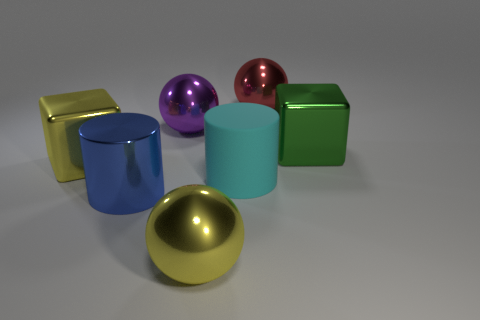Are there any other things that are the same material as the cyan object?
Your response must be concise. No. What material is the cyan object that is the same size as the purple object?
Offer a terse response. Rubber. How many cyan objects are large rubber spheres or rubber cylinders?
Offer a terse response. 1. There is a big object that is to the right of the large rubber cylinder and in front of the big purple metallic object; what color is it?
Provide a short and direct response. Green. Is the material of the red ball that is on the right side of the big purple object the same as the large cube left of the large blue cylinder?
Ensure brevity in your answer.  Yes. Are there more big yellow balls on the right side of the large blue shiny cylinder than big purple balls that are to the right of the green cube?
Ensure brevity in your answer.  Yes. The cyan rubber object that is the same size as the green shiny cube is what shape?
Make the answer very short. Cylinder. What number of objects are either large metal objects or large metallic things that are left of the large purple metal sphere?
Keep it short and to the point. 6. How many yellow shiny objects are behind the large blue cylinder?
Your response must be concise. 1. What is the color of the big cylinder that is the same material as the purple object?
Give a very brief answer. Blue. 